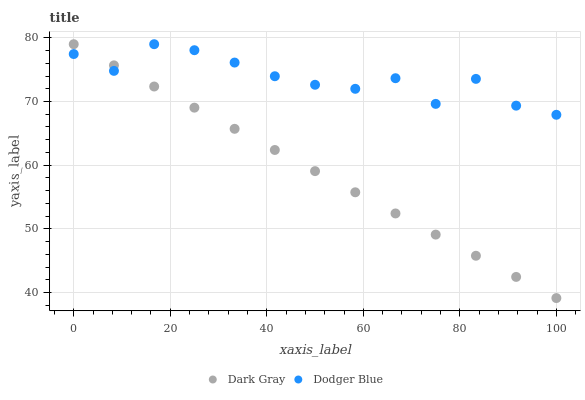Does Dark Gray have the minimum area under the curve?
Answer yes or no. Yes. Does Dodger Blue have the maximum area under the curve?
Answer yes or no. Yes. Does Dodger Blue have the minimum area under the curve?
Answer yes or no. No. Is Dark Gray the smoothest?
Answer yes or no. Yes. Is Dodger Blue the roughest?
Answer yes or no. Yes. Is Dodger Blue the smoothest?
Answer yes or no. No. Does Dark Gray have the lowest value?
Answer yes or no. Yes. Does Dodger Blue have the lowest value?
Answer yes or no. No. Does Dodger Blue have the highest value?
Answer yes or no. Yes. Does Dark Gray intersect Dodger Blue?
Answer yes or no. Yes. Is Dark Gray less than Dodger Blue?
Answer yes or no. No. Is Dark Gray greater than Dodger Blue?
Answer yes or no. No. 